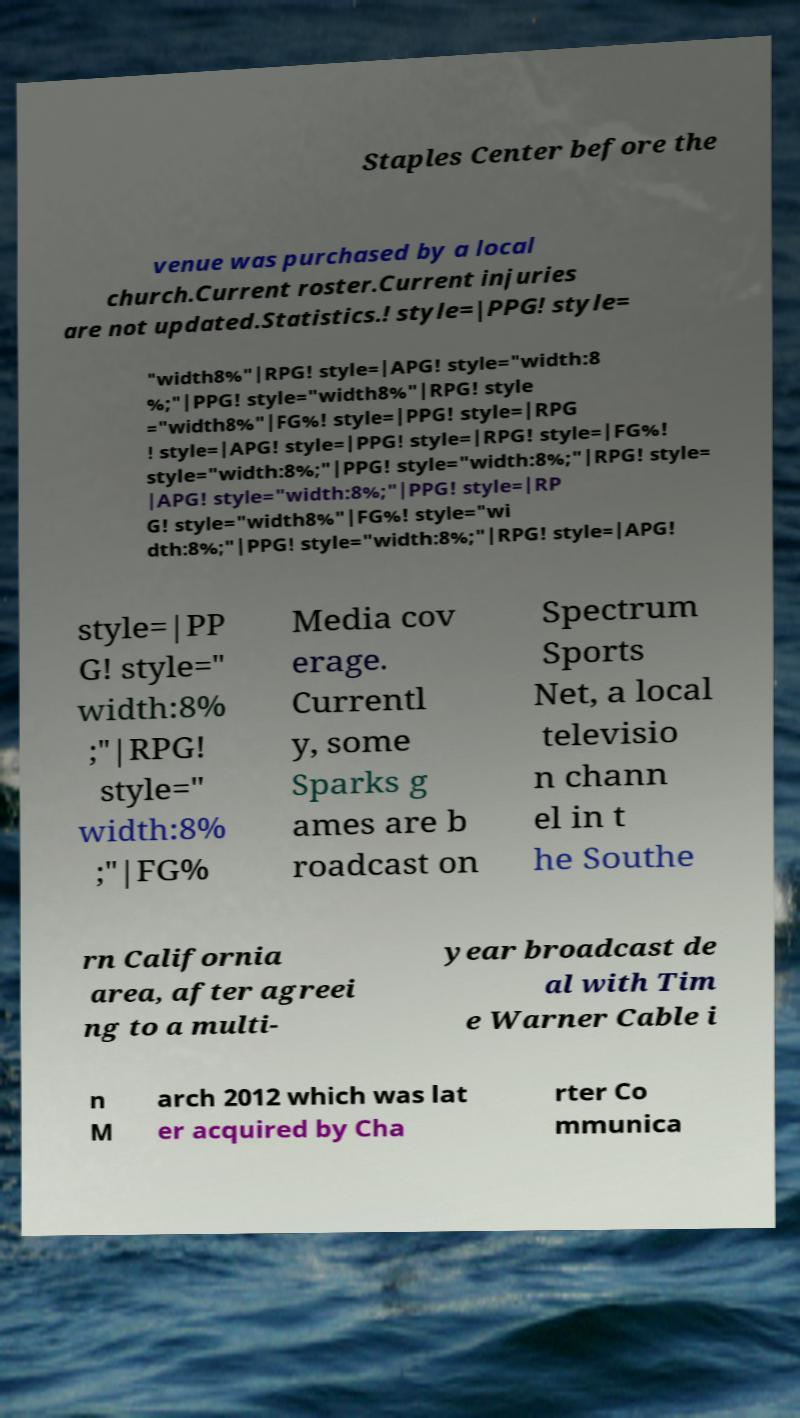There's text embedded in this image that I need extracted. Can you transcribe it verbatim? Staples Center before the venue was purchased by a local church.Current roster.Current injuries are not updated.Statistics.! style=|PPG! style= "width8%"|RPG! style=|APG! style="width:8 %;"|PPG! style="width8%"|RPG! style ="width8%"|FG%! style=|PPG! style=|RPG ! style=|APG! style=|PPG! style=|RPG! style=|FG%! style="width:8%;"|PPG! style="width:8%;"|RPG! style= |APG! style="width:8%;"|PPG! style=|RP G! style="width8%"|FG%! style="wi dth:8%;"|PPG! style="width:8%;"|RPG! style=|APG! style=|PP G! style=" width:8% ;"|RPG! style=" width:8% ;"|FG% Media cov erage. Currentl y, some Sparks g ames are b roadcast on Spectrum Sports Net, a local televisio n chann el in t he Southe rn California area, after agreei ng to a multi- year broadcast de al with Tim e Warner Cable i n M arch 2012 which was lat er acquired by Cha rter Co mmunica 